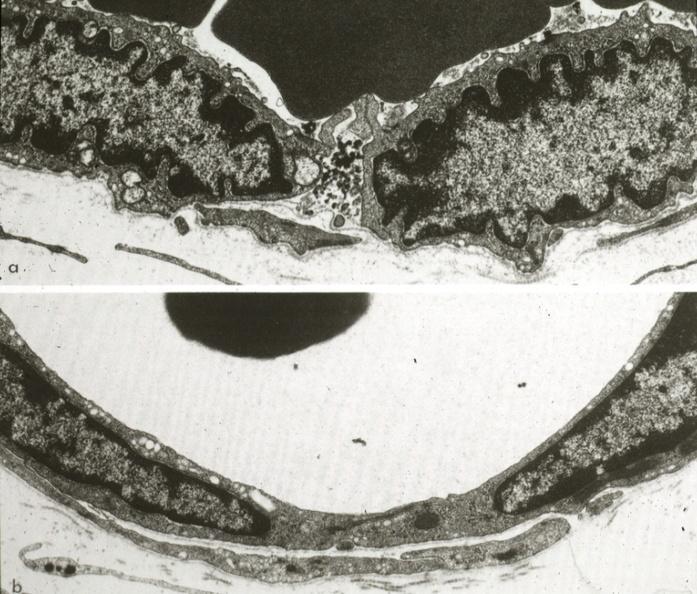what is present?
Answer the question using a single word or phrase. Vasculature 